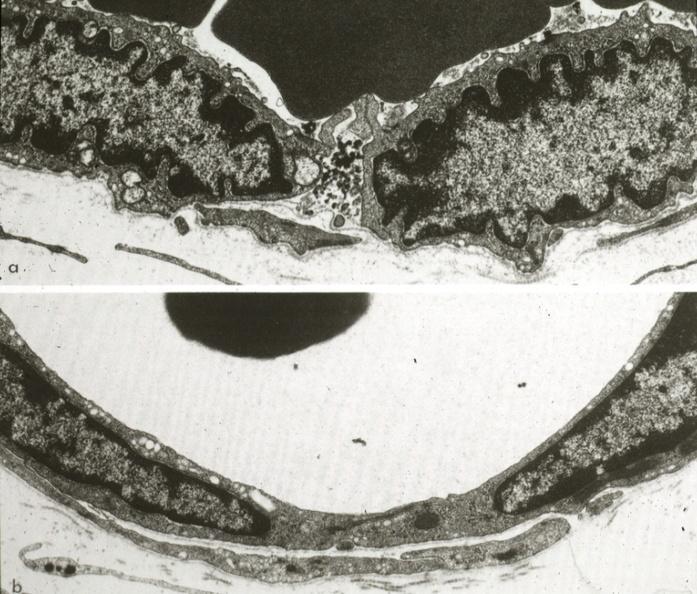what is present?
Answer the question using a single word or phrase. Vasculature 